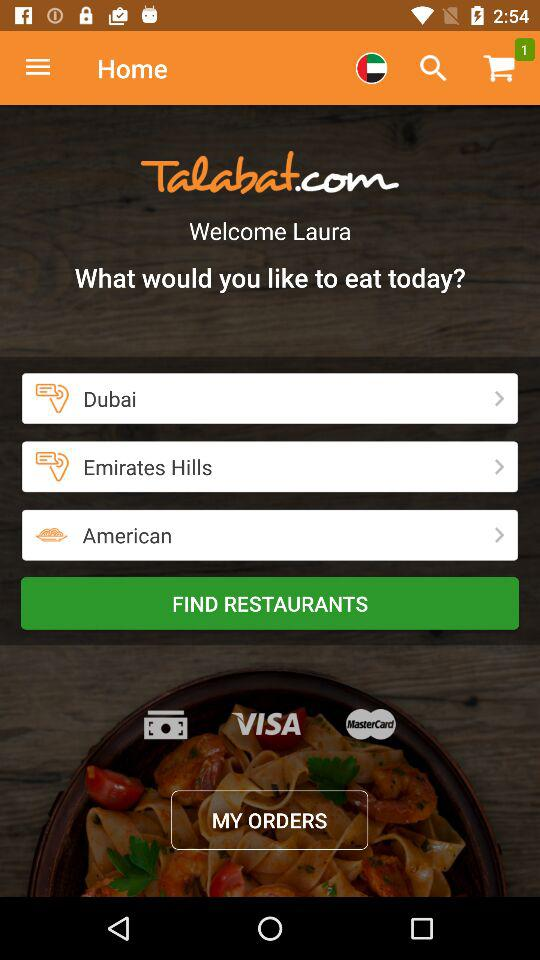How many places can I order food from?
Answer the question using a single word or phrase. 3 